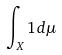<formula> <loc_0><loc_0><loc_500><loc_500>\int _ { X } 1 d \mu</formula> 